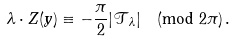Convert formula to latex. <formula><loc_0><loc_0><loc_500><loc_500>\lambda \cdot Z ( y ) \equiv - \frac { \pi } { 2 } | { \mathcal { T } } _ { \lambda } | \pmod { 2 \pi } \, .</formula> 